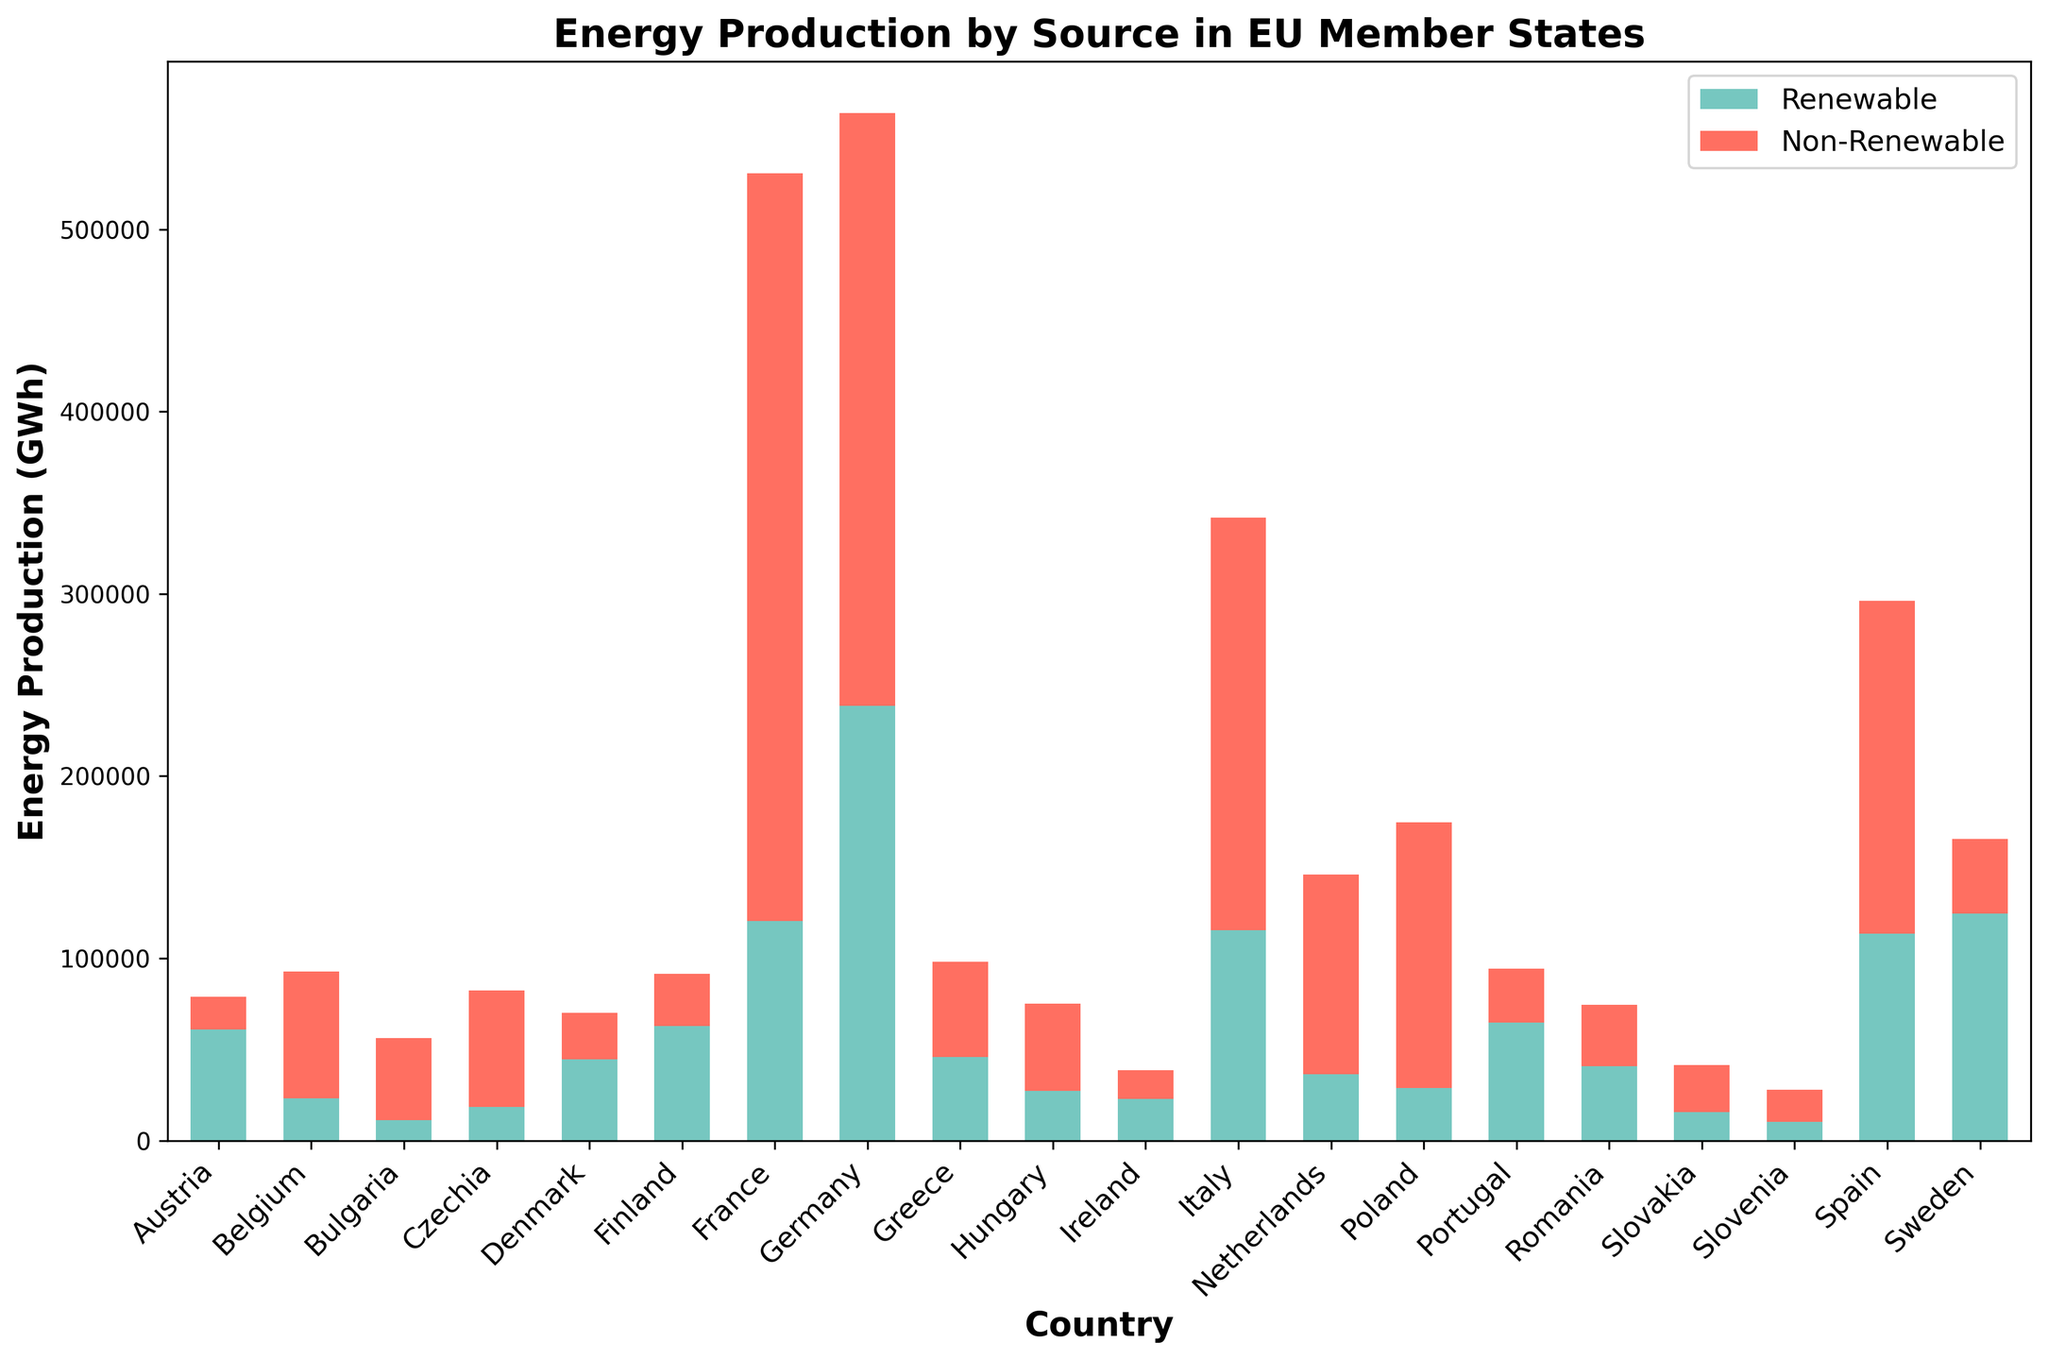Which country produces the highest amount of renewable energy? By looking at the height of the green bars in the figure, we see that Germany's bar is the tallest for renewable energy production.
Answer: Germany How does the total energy production of France compare to Italy? To find the total energy production, add both renewable and non-renewable energy bars for each country. France's total is higher than Italy's.
Answer: France Which country has the smallest amount of non-renewable energy production? The smallest red bar in the figure corresponds to Ireland.
Answer: Ireland What's the sum of renewable energy production in Germany and Spain? Add the height of the green bars for Germany and Spain: 238450 + 113580 = 352030 GWh.
Answer: 352030 GWh Which countries have a higher proportion of renewable energy than non-renewable energy? By comparing the heights of the green and red bars within each country, only Austria and Sweden have taller green bars compared to red ones.
Answer: Austria and Sweden How much greater is Poland's non-renewable energy production compared to its renewable energy production? Subtract the height of the green bar from the red bar for Poland: 145730 - 28860 = 116870 GWh.
Answer: 116870 GWh What is the total energy production for Denmark? Sum the heights of both the green and red bars for Denmark: 44420 + 25700 = 70120 GWh.
Answer: 70120 GWh Which country shows the closest balance between renewable and non-renewable energy production? Compare countries visually to identify nearly equal heights of green and red bars; Greece has the most balanced bars.
Answer: Greece What is the combined non-renewable energy production for Belgium and the Netherlands? Add the red bars for Belgium and the Netherlands: 69400 + 109640 = 179040 GWh.
Answer: 179040 GWh How does Austria's renewable energy production compare to its total energy production? Austria's renewable production is 60860 GWh, and the total production is the sum of green and red bars: 60860 + 17930 = 78790 GWh. Renewable energy makes up a significant portion of the total.
Answer: 60860 / 78790 GWh 